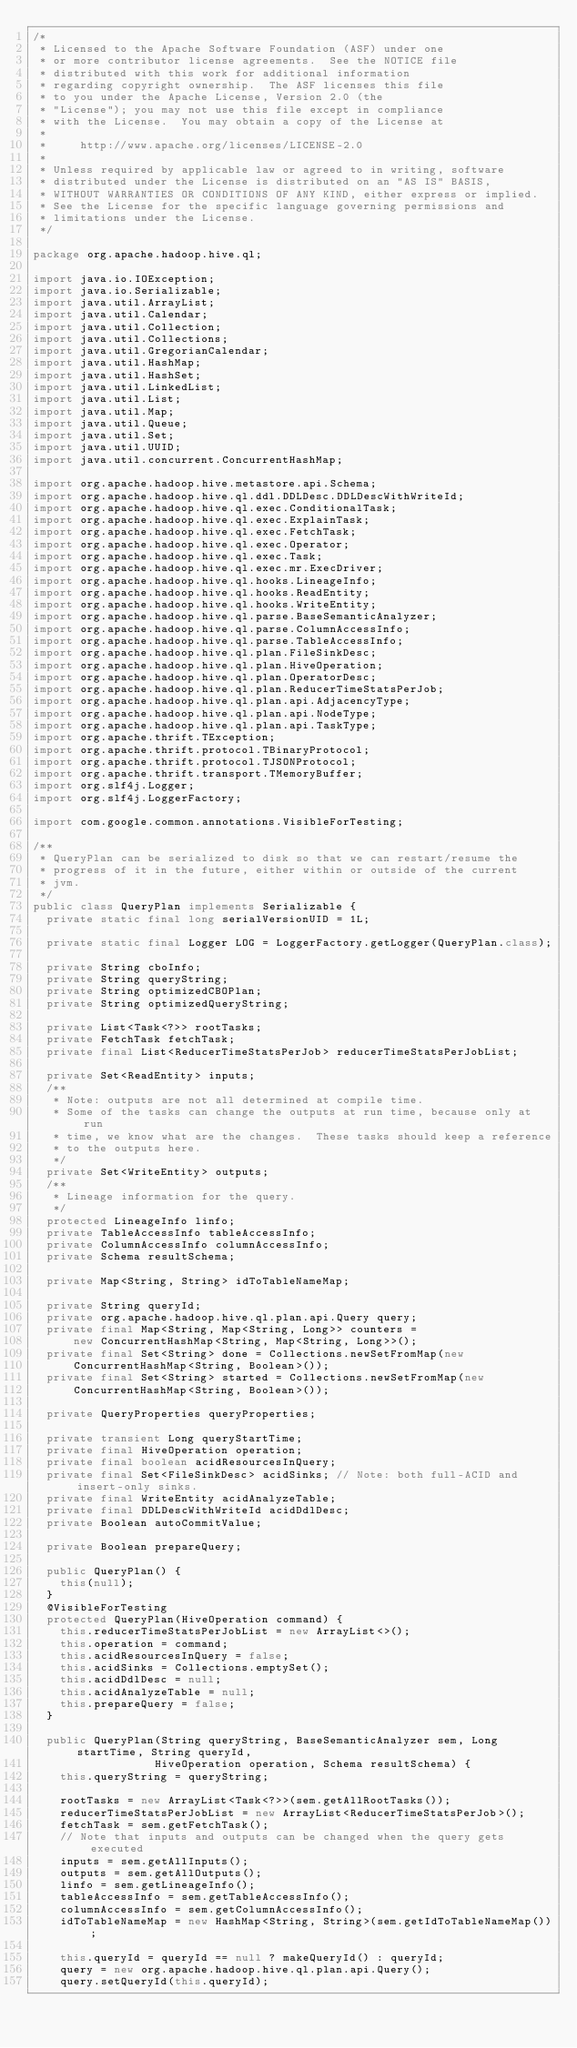<code> <loc_0><loc_0><loc_500><loc_500><_Java_>/*
 * Licensed to the Apache Software Foundation (ASF) under one
 * or more contributor license agreements.  See the NOTICE file
 * distributed with this work for additional information
 * regarding copyright ownership.  The ASF licenses this file
 * to you under the Apache License, Version 2.0 (the
 * "License"); you may not use this file except in compliance
 * with the License.  You may obtain a copy of the License at
 *
 *     http://www.apache.org/licenses/LICENSE-2.0
 *
 * Unless required by applicable law or agreed to in writing, software
 * distributed under the License is distributed on an "AS IS" BASIS,
 * WITHOUT WARRANTIES OR CONDITIONS OF ANY KIND, either express or implied.
 * See the License for the specific language governing permissions and
 * limitations under the License.
 */

package org.apache.hadoop.hive.ql;

import java.io.IOException;
import java.io.Serializable;
import java.util.ArrayList;
import java.util.Calendar;
import java.util.Collection;
import java.util.Collections;
import java.util.GregorianCalendar;
import java.util.HashMap;
import java.util.HashSet;
import java.util.LinkedList;
import java.util.List;
import java.util.Map;
import java.util.Queue;
import java.util.Set;
import java.util.UUID;
import java.util.concurrent.ConcurrentHashMap;

import org.apache.hadoop.hive.metastore.api.Schema;
import org.apache.hadoop.hive.ql.ddl.DDLDesc.DDLDescWithWriteId;
import org.apache.hadoop.hive.ql.exec.ConditionalTask;
import org.apache.hadoop.hive.ql.exec.ExplainTask;
import org.apache.hadoop.hive.ql.exec.FetchTask;
import org.apache.hadoop.hive.ql.exec.Operator;
import org.apache.hadoop.hive.ql.exec.Task;
import org.apache.hadoop.hive.ql.exec.mr.ExecDriver;
import org.apache.hadoop.hive.ql.hooks.LineageInfo;
import org.apache.hadoop.hive.ql.hooks.ReadEntity;
import org.apache.hadoop.hive.ql.hooks.WriteEntity;
import org.apache.hadoop.hive.ql.parse.BaseSemanticAnalyzer;
import org.apache.hadoop.hive.ql.parse.ColumnAccessInfo;
import org.apache.hadoop.hive.ql.parse.TableAccessInfo;
import org.apache.hadoop.hive.ql.plan.FileSinkDesc;
import org.apache.hadoop.hive.ql.plan.HiveOperation;
import org.apache.hadoop.hive.ql.plan.OperatorDesc;
import org.apache.hadoop.hive.ql.plan.ReducerTimeStatsPerJob;
import org.apache.hadoop.hive.ql.plan.api.AdjacencyType;
import org.apache.hadoop.hive.ql.plan.api.NodeType;
import org.apache.hadoop.hive.ql.plan.api.TaskType;
import org.apache.thrift.TException;
import org.apache.thrift.protocol.TBinaryProtocol;
import org.apache.thrift.protocol.TJSONProtocol;
import org.apache.thrift.transport.TMemoryBuffer;
import org.slf4j.Logger;
import org.slf4j.LoggerFactory;

import com.google.common.annotations.VisibleForTesting;

/**
 * QueryPlan can be serialized to disk so that we can restart/resume the
 * progress of it in the future, either within or outside of the current
 * jvm.
 */
public class QueryPlan implements Serializable {
  private static final long serialVersionUID = 1L;

  private static final Logger LOG = LoggerFactory.getLogger(QueryPlan.class);

  private String cboInfo;
  private String queryString;
  private String optimizedCBOPlan;
  private String optimizedQueryString;

  private List<Task<?>> rootTasks;
  private FetchTask fetchTask;
  private final List<ReducerTimeStatsPerJob> reducerTimeStatsPerJobList;

  private Set<ReadEntity> inputs;
  /**
   * Note: outputs are not all determined at compile time.
   * Some of the tasks can change the outputs at run time, because only at run
   * time, we know what are the changes.  These tasks should keep a reference
   * to the outputs here.
   */
  private Set<WriteEntity> outputs;
  /**
   * Lineage information for the query.
   */
  protected LineageInfo linfo;
  private TableAccessInfo tableAccessInfo;
  private ColumnAccessInfo columnAccessInfo;
  private Schema resultSchema;

  private Map<String, String> idToTableNameMap;

  private String queryId;
  private org.apache.hadoop.hive.ql.plan.api.Query query;
  private final Map<String, Map<String, Long>> counters =
      new ConcurrentHashMap<String, Map<String, Long>>();
  private final Set<String> done = Collections.newSetFromMap(new
      ConcurrentHashMap<String, Boolean>());
  private final Set<String> started = Collections.newSetFromMap(new
      ConcurrentHashMap<String, Boolean>());

  private QueryProperties queryProperties;

  private transient Long queryStartTime;
  private final HiveOperation operation;
  private final boolean acidResourcesInQuery;
  private final Set<FileSinkDesc> acidSinks; // Note: both full-ACID and insert-only sinks.
  private final WriteEntity acidAnalyzeTable;
  private final DDLDescWithWriteId acidDdlDesc;
  private Boolean autoCommitValue;

  private Boolean prepareQuery;

  public QueryPlan() {
    this(null);
  }
  @VisibleForTesting
  protected QueryPlan(HiveOperation command) {
    this.reducerTimeStatsPerJobList = new ArrayList<>();
    this.operation = command;
    this.acidResourcesInQuery = false;
    this.acidSinks = Collections.emptySet();
    this.acidDdlDesc = null;
    this.acidAnalyzeTable = null;
    this.prepareQuery = false;
  }

  public QueryPlan(String queryString, BaseSemanticAnalyzer sem, Long startTime, String queryId,
                  HiveOperation operation, Schema resultSchema) {
    this.queryString = queryString;

    rootTasks = new ArrayList<Task<?>>(sem.getAllRootTasks());
    reducerTimeStatsPerJobList = new ArrayList<ReducerTimeStatsPerJob>();
    fetchTask = sem.getFetchTask();
    // Note that inputs and outputs can be changed when the query gets executed
    inputs = sem.getAllInputs();
    outputs = sem.getAllOutputs();
    linfo = sem.getLineageInfo();
    tableAccessInfo = sem.getTableAccessInfo();
    columnAccessInfo = sem.getColumnAccessInfo();
    idToTableNameMap = new HashMap<String, String>(sem.getIdToTableNameMap());

    this.queryId = queryId == null ? makeQueryId() : queryId;
    query = new org.apache.hadoop.hive.ql.plan.api.Query();
    query.setQueryId(this.queryId);</code> 